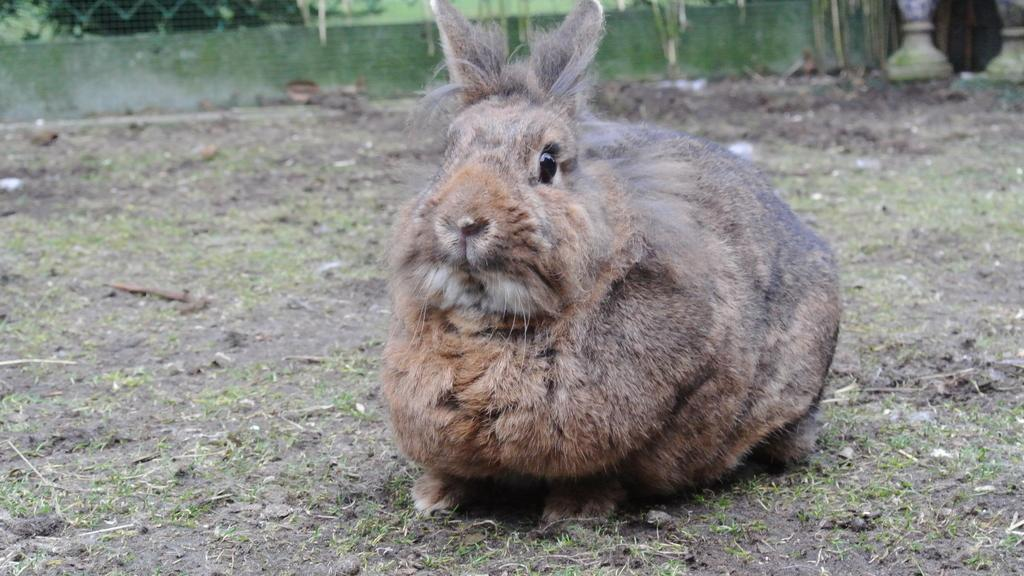What can be seen in the background of the image? There is a fence in the background of the image. What animal is present on the ground in the image? There is a rabbit on the ground in the image. Where is the suit hanging in the image? There is no suit present in the image. What type of glass object can be seen on the shelf in the image? There is no shelf or glass object present in the image. 